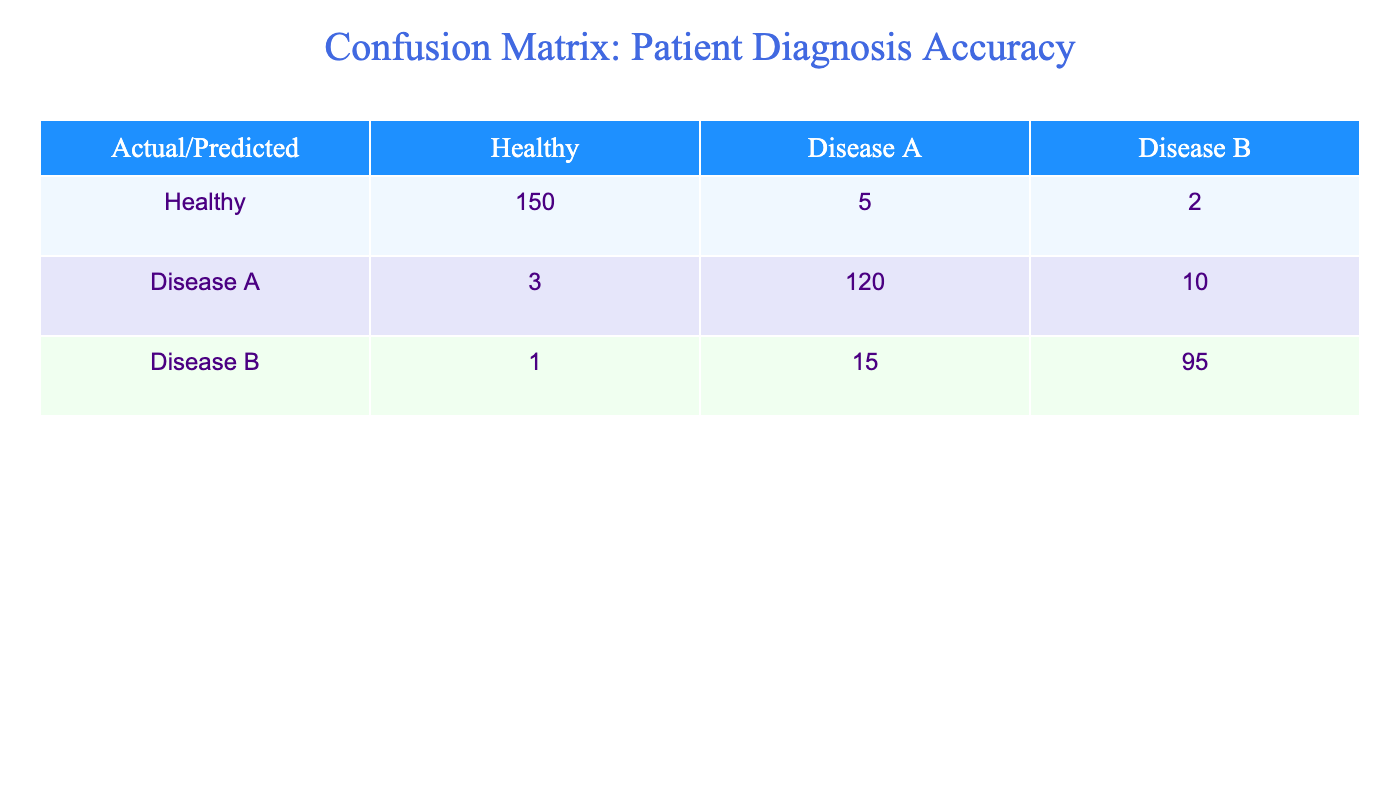What is the total number of patients who were diagnosed as Healthy? To find the total number of patients diagnosed as Healthy, we look at the row for Healthy in the table. The values are 150 for Healthy, 5 for Disease A, and 2 for Disease B. The total is simply the value for Healthy, which is 150.
Answer: 150 How many patients were misdiagnosed as Disease A? In the Disease A row, we can identify the patients who were misdiagnosed. The values in this row are 3 (Healthy), 120 (Disease A), and 10 (Disease B). The misdiagnosis corresponds to the Healthy patients who were incorrectly identified as having Disease A, which is 3.
Answer: 3 What percentage of patients correctly diagnosed as Disease B? To find the percentage of patients correctly diagnosed as Disease B, we take the true positive value from the Disease B row, which is 95, and divide it by the total number of patients in that row (1 + 15 + 95 = 111). Then we multiply by 100 to get the percentage: (95/111) * 100 ≈ 85.59%.
Answer: 85.59% Which disease had the highest number of false negatives? False negatives for each disease can be identified by looking at the actual occurrences versus predicted occurrences. For Disease A, we see 3 (Healthy) + 10 (Disease B) = 13 false negatives. For Disease B, it would include 1 (Healthy) + 15 (Disease A) = 16 false negatives. The Disease B has the highest number of false negatives.
Answer: Disease B What is the ratio of Healthy patients to patients diagnosed with Disease A? To find the ratio, we look at the number of Healthy patients, which is 150, and patients diagnosed as Disease A, which is 120. The ratio can be calculated as follows: 150 (Healthy) to 120 (Disease A) reduces to 5:4 after dividing both by 30.
Answer: 5:4 Is it true that Disease A had more correct diagnoses than false diagnoses? We check the Disease A row for the number of correct diagnoses (120) versus incorrect diagnoses (3 false negatives + 10 false positives = 13). Here, 120 (correct) is indeed greater than 13 (incorrect). Therefore, the statement is true.
Answer: Yes How many total misclassifications are there? Misclassifications are all incorrect predictions, which can be identified by looking at the off-diagonal values in the table. We add together 5 (Healthy to Disease A) + 2 (Healthy to Disease B) + 3 (Disease A to Healthy) + 10 (Disease A to Disease B) + 1 (Disease B to Healthy) + 15 (Disease B to Disease A), resulting in 5 + 2 + 3 + 10 + 1 + 15 = 36.
Answer: 36 What is the average number of healthy patients and patients diagnosed with Disease A? To calculate the average, we take the number of Healthy patients (150) and patients diagnosed with Disease A (120). We add them together (150 + 120 = 270), and divide by the number of groups (2): 270/2 = 135.
Answer: 135 